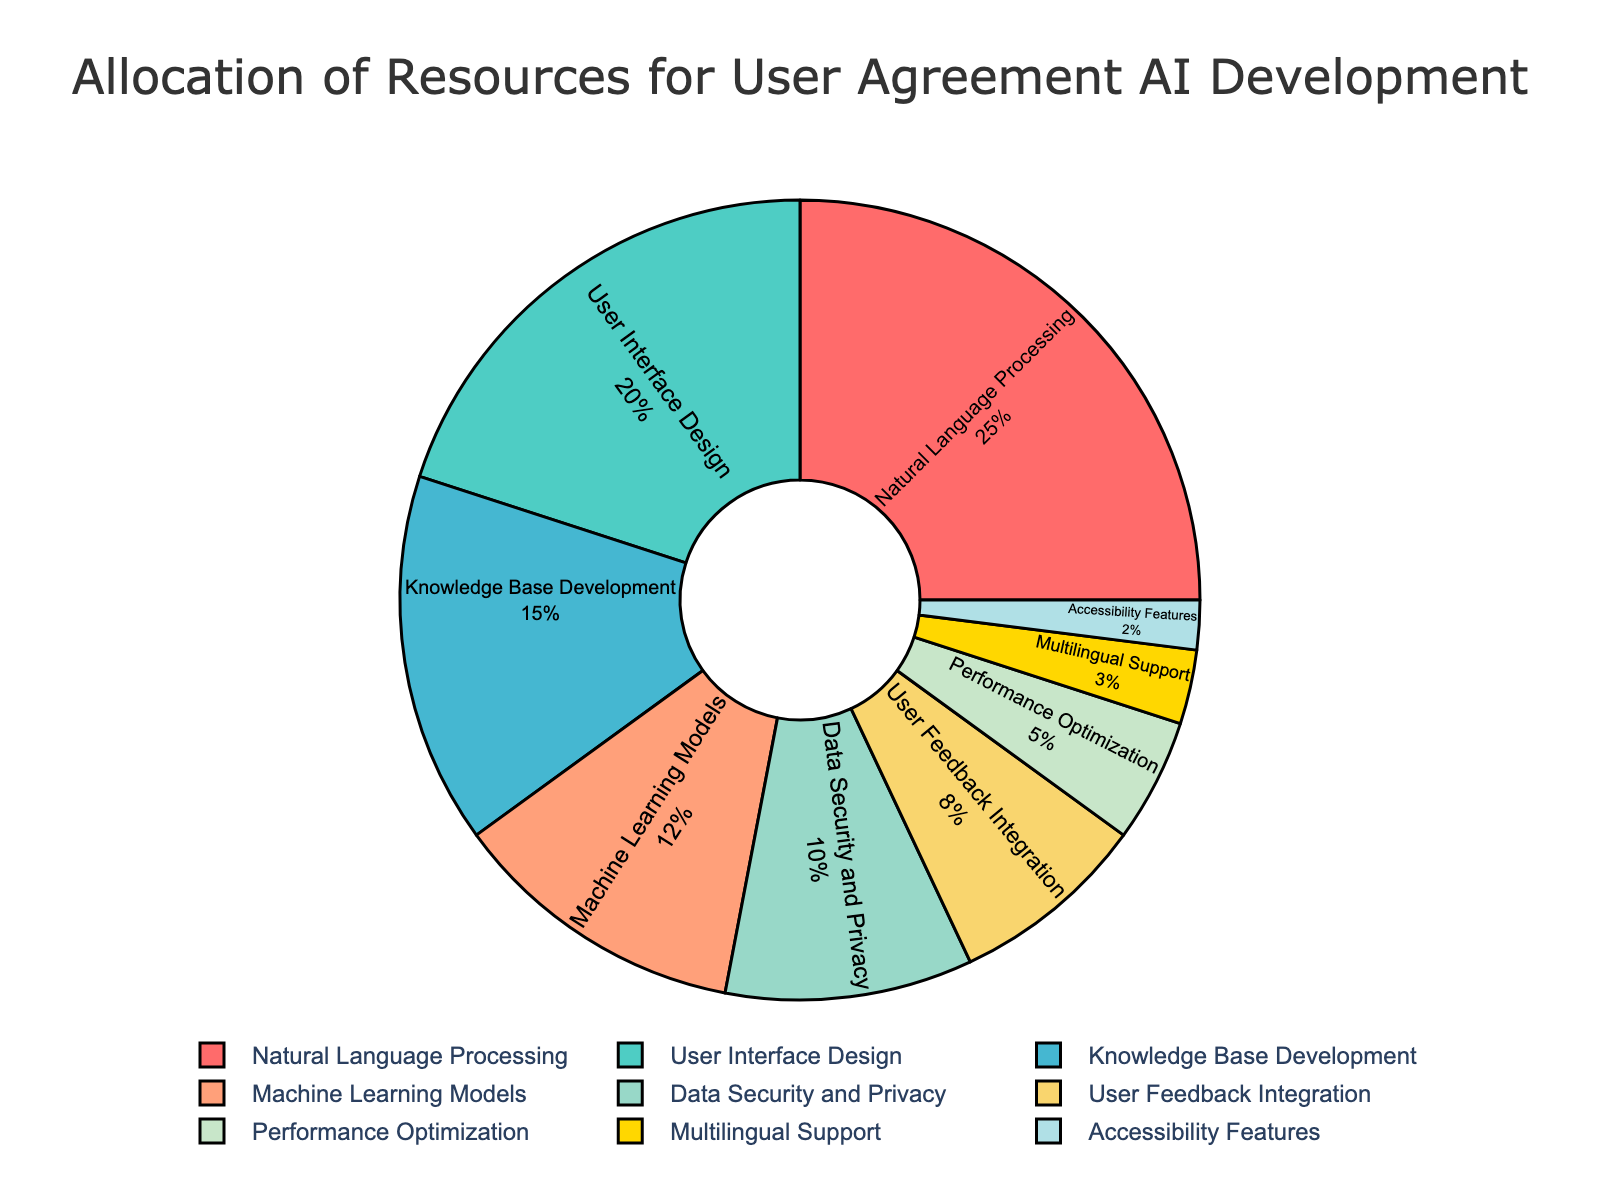What are the two largest categories in terms of resource allocation? To find the two largest categories, refer to the percentages listed next to each category on the pie chart. The two largest percentages are 25% for Natural Language Processing and 20% for User Interface Design.
Answer: Natural Language Processing and User Interface Design What is the total percentage of resources allocated to Machine Learning Models and Data Security and Privacy combined? To find the total percentage, add the percentages of Machine Learning Models and Data Security and Privacy. This is 12% + 10% = 22%.
Answer: 22% Which category has the smallest allocation of resources? To identify the smallest allocation, look at the percentages in the pie chart. The smallest percentage is 2%, which corresponds to Accessibility Features.
Answer: Accessibility Features Are more resources allocated to Knowledge Base Development or User Feedback Integration? Compare the percentages. Knowledge Base Development has 15% allocated, while User Feedback Integration has 8%. Since 15% is greater than 8%, more resources are allocated to Knowledge Base Development.
Answer: Knowledge Base Development How much more is allocated to Natural Language Processing than to Multilingual Support? Determine the difference in percentages between Natural Language Processing and Multilingual Support. This is 25% - 3% = 22%.
Answer: 22% What is the combined percentage of resources allocated to the three smallest categories? Identify the three smallest categories: Accessibility Features (2%), Multilingual Support (3%), and Performance Optimization (5%). Add these percentages: 2% + 3% + 5% = 10%.
Answer: 10% Compare the resources allocated to User Interface Design and Knowledge Base Development. Which one is larger and by how much? Examine the percentages for User Interface Design (20%) and Knowledge Base Development (15%). User Interface Design is larger. The difference is 20% - 15% = 5%.
Answer: User Interface Design by 5% What color represents Data Security and Privacy in the pie chart? To determine the color, locate Data Security and Privacy on the pie chart and identify the color assigned to this section. It is represented by the fifth color, which is a shade of yellow.
Answer: Yellow Is the allocation for Data Security and Privacy greater or less than the allocation for User Feedback Integration? Compare their percentages. Data Security and Privacy is at 10%, and User Feedback Integration is at 8%. Therefore, Data Security and Privacy has a greater allocation.
Answer: Greater How many categories have an allocation greater than 10%? Identify all categories with percentages greater than 10%: Natural Language Processing (25%), User Interface Design (20%), Knowledge Base Development (15%), Machine Learning Models (12%), and Data Security and Privacy (10%). Since 10% is included in greater than 10%, there are 5 categories.
Answer: 5 